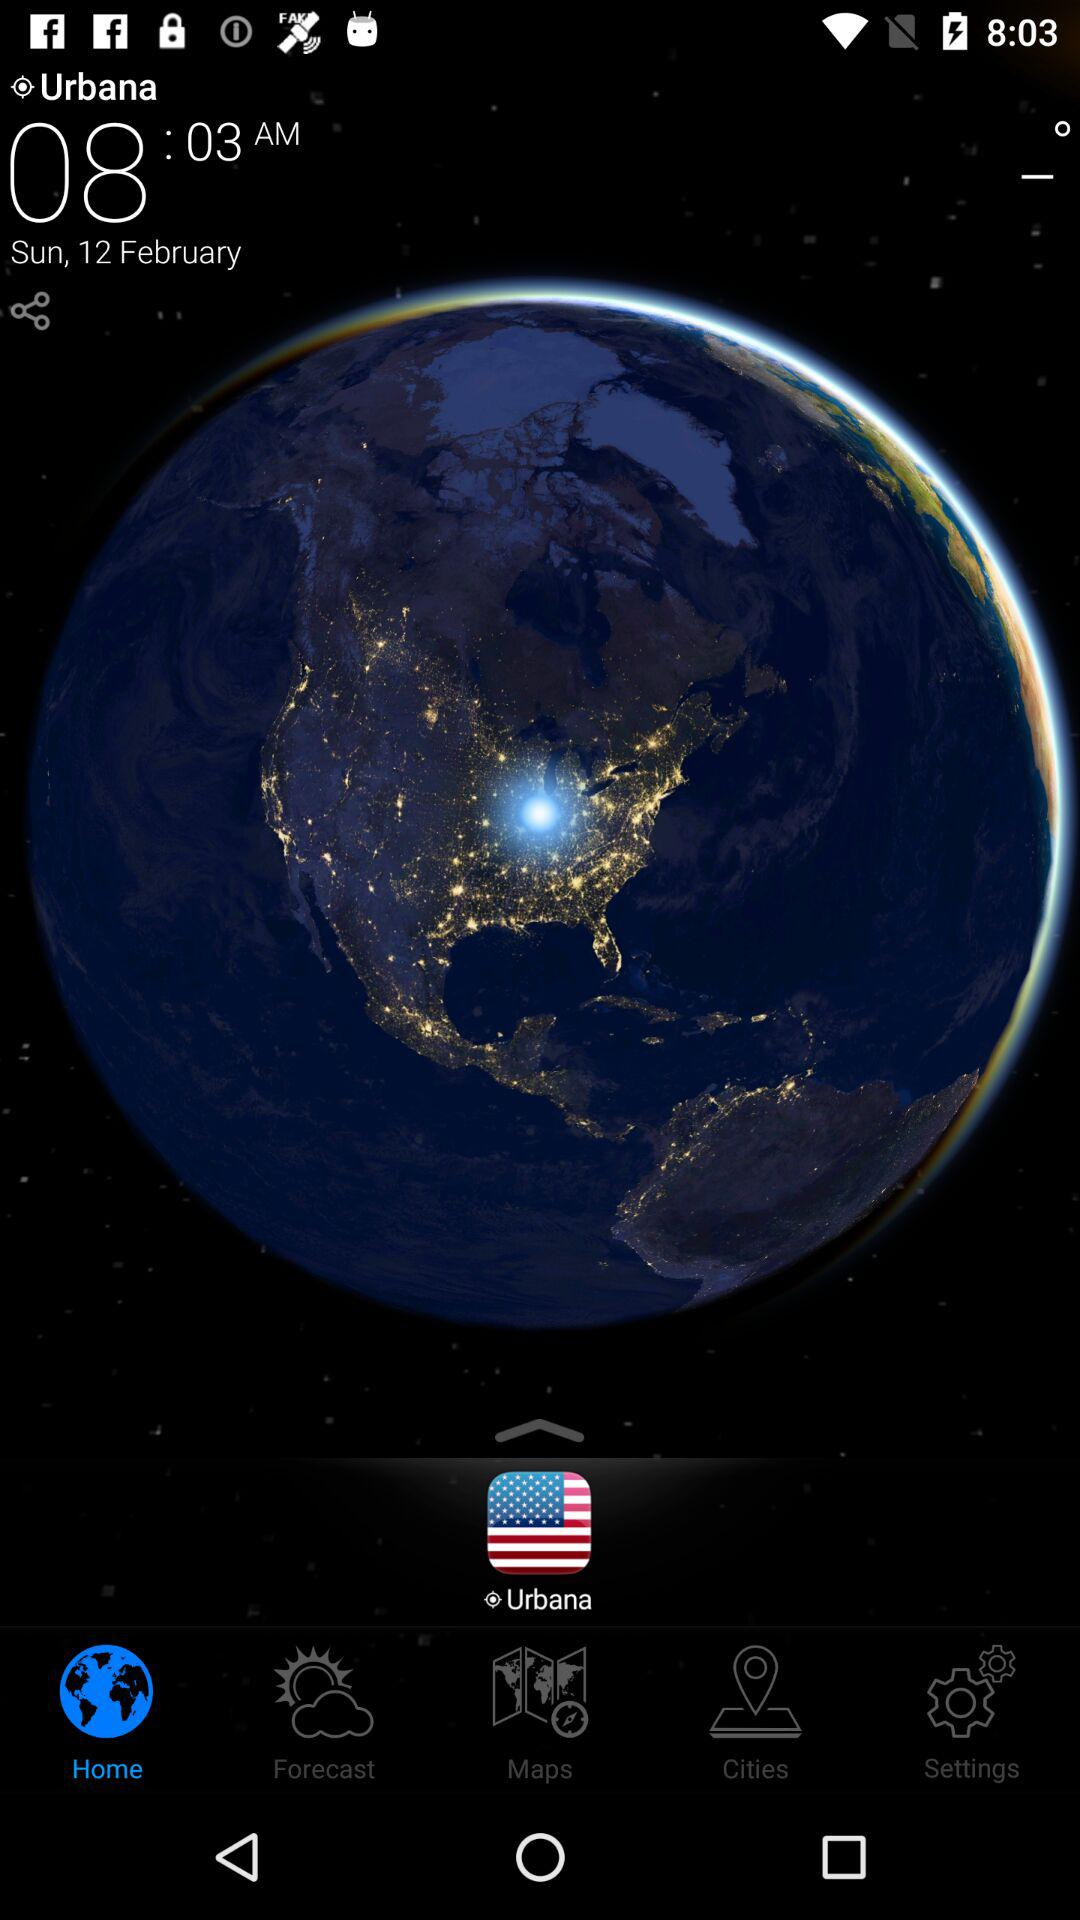What day is on February 12? The day is Sunday. 